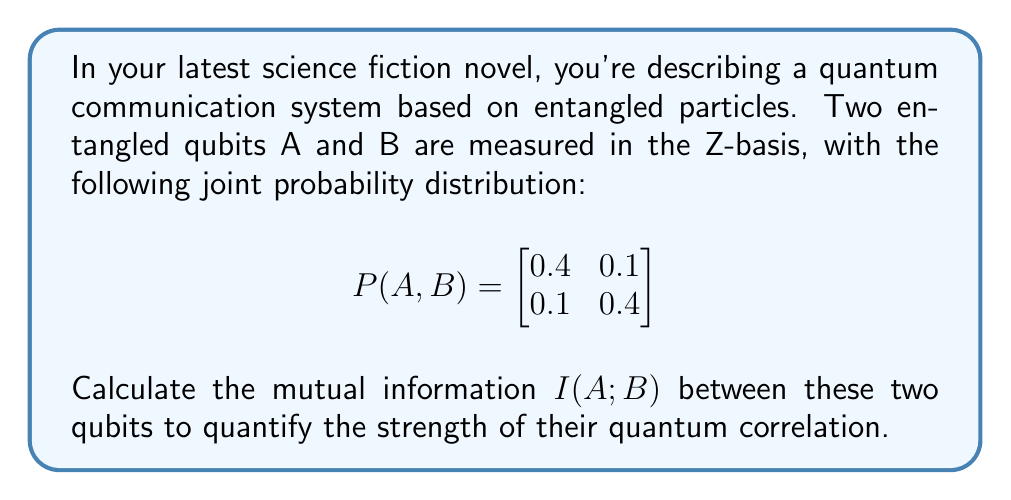Show me your answer to this math problem. To calculate the mutual information $I(A;B)$, we'll follow these steps:

1) First, we need to find the marginal probabilities $P(A)$ and $P(B)$:

   $P(A=0) = 0.4 + 0.1 = 0.5$
   $P(A=1) = 0.1 + 0.4 = 0.5$
   $P(B=0) = 0.4 + 0.1 = 0.5$
   $P(B=1) = 0.1 + 0.4 = 0.5$

2) The mutual information is defined as:

   $I(A;B) = \sum_{a,b} P(a,b) \log_2 \frac{P(a,b)}{P(a)P(b)}$

3) Let's calculate each term:

   For $A=0, B=0$: $0.4 \log_2 \frac{0.4}{0.5 \cdot 0.5} = 0.4 \log_2 1.6 = 0.4 \cdot 0.678 = 0.2712$
   
   For $A=0, B=1$: $0.1 \log_2 \frac{0.1}{0.5 \cdot 0.5} = 0.1 \log_2 0.4 = 0.1 \cdot (-1.322) = -0.1322$
   
   For $A=1, B=0$: $0.1 \log_2 \frac{0.1}{0.5 \cdot 0.5} = 0.1 \log_2 0.4 = 0.1 \cdot (-1.322) = -0.1322$
   
   For $A=1, B=1$: $0.4 \log_2 \frac{0.4}{0.5 \cdot 0.5} = 0.4 \log_2 1.6 = 0.4 \cdot 0.678 = 0.2712$

4) Sum all these terms:

   $I(A;B) = 0.2712 - 0.1322 - 0.1322 + 0.2712 = 0.278$ bits

This value indicates a significant correlation between the qubits, as the maximum mutual information for two binary variables is 1 bit.
Answer: $I(A;B) = 0.278$ bits 